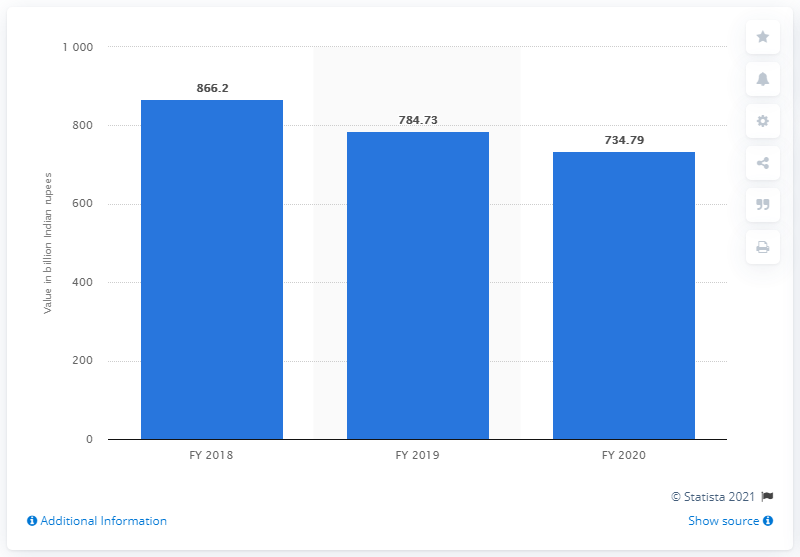Point out several critical features in this image. Punjab National Bank's gross non-performing assets at the end of FY 2020 were 734.79. 